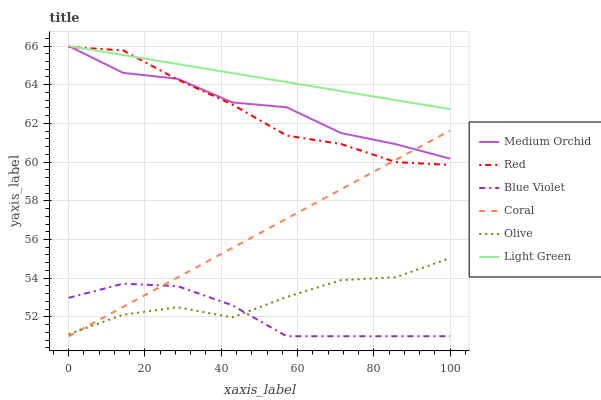Does Blue Violet have the minimum area under the curve?
Answer yes or no. Yes. Does Light Green have the maximum area under the curve?
Answer yes or no. Yes. Does Medium Orchid have the minimum area under the curve?
Answer yes or no. No. Does Medium Orchid have the maximum area under the curve?
Answer yes or no. No. Is Light Green the smoothest?
Answer yes or no. Yes. Is Medium Orchid the roughest?
Answer yes or no. Yes. Is Red the smoothest?
Answer yes or no. No. Is Red the roughest?
Answer yes or no. No. Does Medium Orchid have the lowest value?
Answer yes or no. No. Does Red have the highest value?
Answer yes or no. No. Is Blue Violet less than Light Green?
Answer yes or no. Yes. Is Light Green greater than Blue Violet?
Answer yes or no. Yes. Does Blue Violet intersect Light Green?
Answer yes or no. No. 